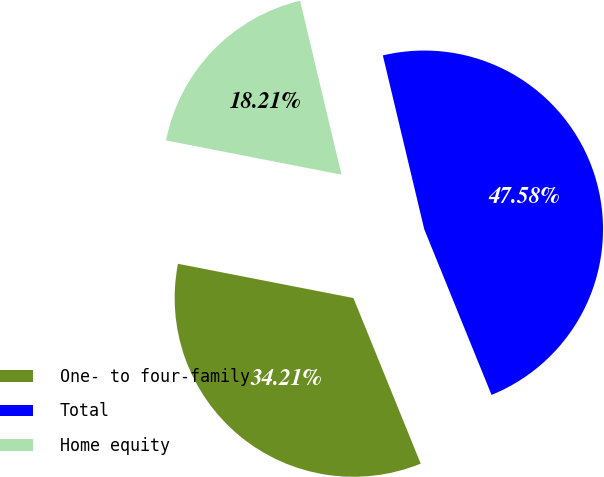<chart> <loc_0><loc_0><loc_500><loc_500><pie_chart><fcel>One- to four-family<fcel>Total<fcel>Home equity<nl><fcel>34.21%<fcel>47.58%<fcel>18.21%<nl></chart> 